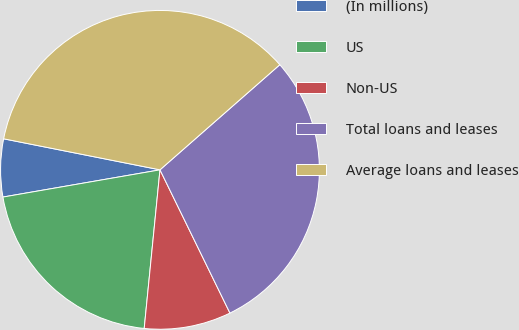<chart> <loc_0><loc_0><loc_500><loc_500><pie_chart><fcel>(In millions)<fcel>US<fcel>Non-US<fcel>Total loans and leases<fcel>Average loans and leases<nl><fcel>5.85%<fcel>20.69%<fcel>8.81%<fcel>29.23%<fcel>35.42%<nl></chart> 